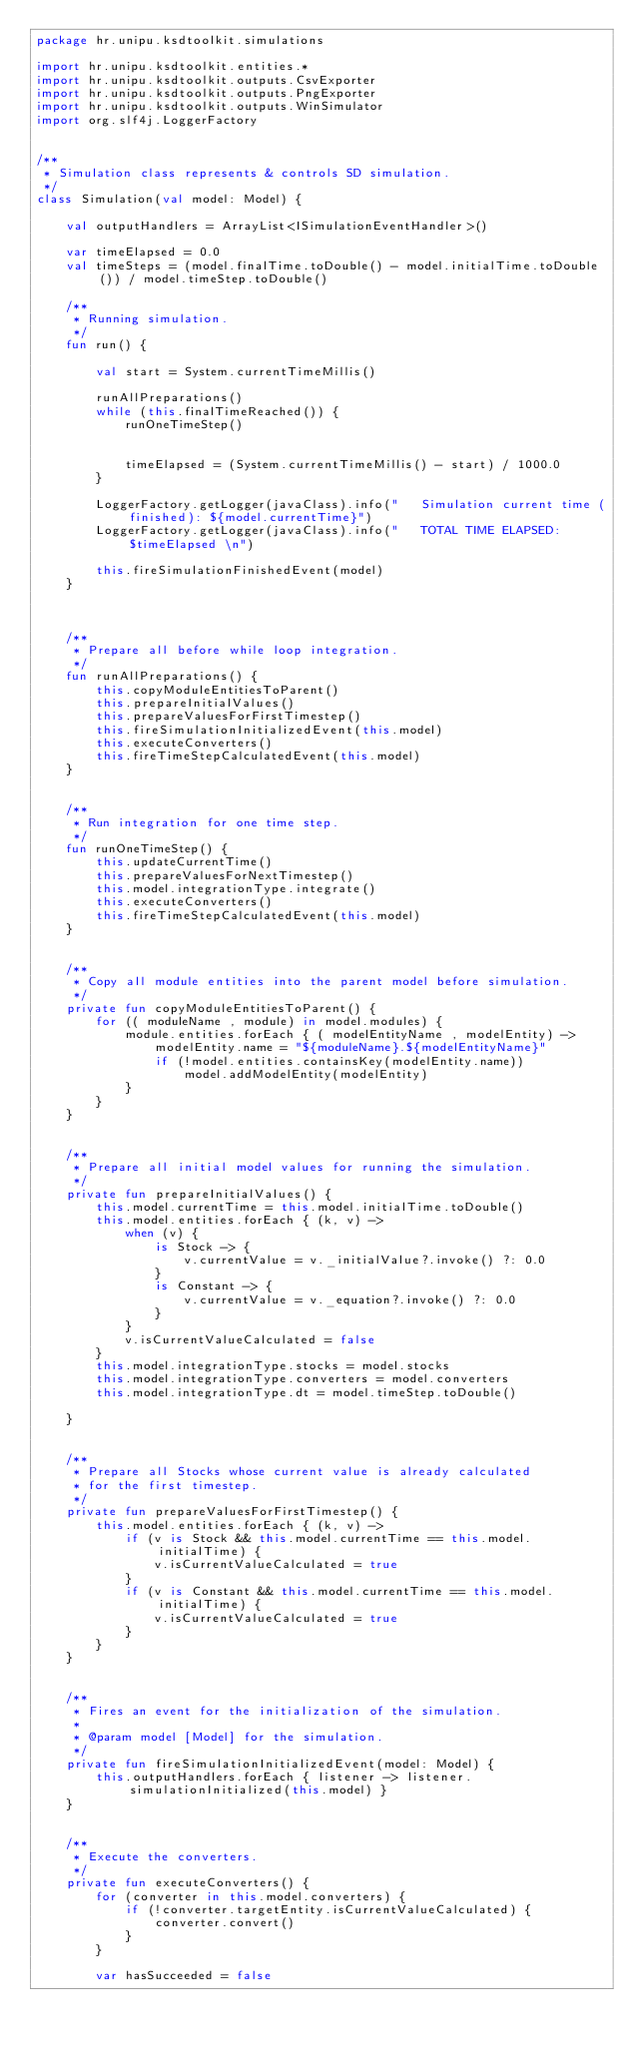Convert code to text. <code><loc_0><loc_0><loc_500><loc_500><_Kotlin_>package hr.unipu.ksdtoolkit.simulations

import hr.unipu.ksdtoolkit.entities.*
import hr.unipu.ksdtoolkit.outputs.CsvExporter
import hr.unipu.ksdtoolkit.outputs.PngExporter
import hr.unipu.ksdtoolkit.outputs.WinSimulator
import org.slf4j.LoggerFactory


/**
 * Simulation class represents & controls SD simulation.
 */
class Simulation(val model: Model) {

    val outputHandlers = ArrayList<ISimulationEventHandler>()

    var timeElapsed = 0.0
    val timeSteps = (model.finalTime.toDouble() - model.initialTime.toDouble()) / model.timeStep.toDouble()

    /**
     * Running simulation.
     */
    fun run() {

        val start = System.currentTimeMillis()

        runAllPreparations()
        while (this.finalTimeReached()) {
            runOneTimeStep()


            timeElapsed = (System.currentTimeMillis() - start) / 1000.0
        }

        LoggerFactory.getLogger(javaClass).info("   Simulation current time (finished): ${model.currentTime}")
        LoggerFactory.getLogger(javaClass).info("   TOTAL TIME ELAPSED: $timeElapsed \n")

        this.fireSimulationFinishedEvent(model)
    }



    /**
     * Prepare all before while loop integration.
     */
    fun runAllPreparations() {
        this.copyModuleEntitiesToParent()
        this.prepareInitialValues()
        this.prepareValuesForFirstTimestep()
        this.fireSimulationInitializedEvent(this.model)
        this.executeConverters()
        this.fireTimeStepCalculatedEvent(this.model)
    }


    /**
     * Run integration for one time step.
     */
    fun runOneTimeStep() {
        this.updateCurrentTime()
        this.prepareValuesForNextTimestep()
        this.model.integrationType.integrate()
        this.executeConverters()
        this.fireTimeStepCalculatedEvent(this.model)
    }


    /**
     * Copy all module entities into the parent model before simulation.
     */
    private fun copyModuleEntitiesToParent() {
        for (( moduleName , module) in model.modules) {
            module.entities.forEach { ( modelEntityName , modelEntity) ->
                modelEntity.name = "${moduleName}.${modelEntityName}"
                if (!model.entities.containsKey(modelEntity.name))
                    model.addModelEntity(modelEntity)
            }
        }
    }


    /**
     * Prepare all initial model values for running the simulation.
     */
    private fun prepareInitialValues() {
        this.model.currentTime = this.model.initialTime.toDouble()
        this.model.entities.forEach { (k, v) ->
            when (v) {
                is Stock -> {
                    v.currentValue = v._initialValue?.invoke() ?: 0.0
                }
                is Constant -> {
                    v.currentValue = v._equation?.invoke() ?: 0.0
                }
            }
            v.isCurrentValueCalculated = false
        }
        this.model.integrationType.stocks = model.stocks
        this.model.integrationType.converters = model.converters
        this.model.integrationType.dt = model.timeStep.toDouble()

    }


    /**
     * Prepare all Stocks whose current value is already calculated
     * for the first timestep.
     */
    private fun prepareValuesForFirstTimestep() {
        this.model.entities.forEach { (k, v) ->
            if (v is Stock && this.model.currentTime == this.model.initialTime) {
                v.isCurrentValueCalculated = true
            }
            if (v is Constant && this.model.currentTime == this.model.initialTime) {
                v.isCurrentValueCalculated = true
            }
        }
    }


    /**
     * Fires an event for the initialization of the simulation.
     *
     * @param model [Model] for the simulation.
     */
    private fun fireSimulationInitializedEvent(model: Model) {
        this.outputHandlers.forEach { listener -> listener.simulationInitialized(this.model) }
    }


    /**
     * Execute the converters.
     */
    private fun executeConverters() {
        for (converter in this.model.converters) {
            if (!converter.targetEntity.isCurrentValueCalculated) {
                converter.convert()
            }
        }

        var hasSucceeded = false</code> 